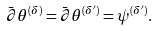Convert formula to latex. <formula><loc_0><loc_0><loc_500><loc_500>\bar { \partial } \theta ^ { ( \delta ) } = \bar { \partial } \theta ^ { ( \delta ^ { \prime } ) } = \psi ^ { ( \delta ^ { \prime } ) } .</formula> 